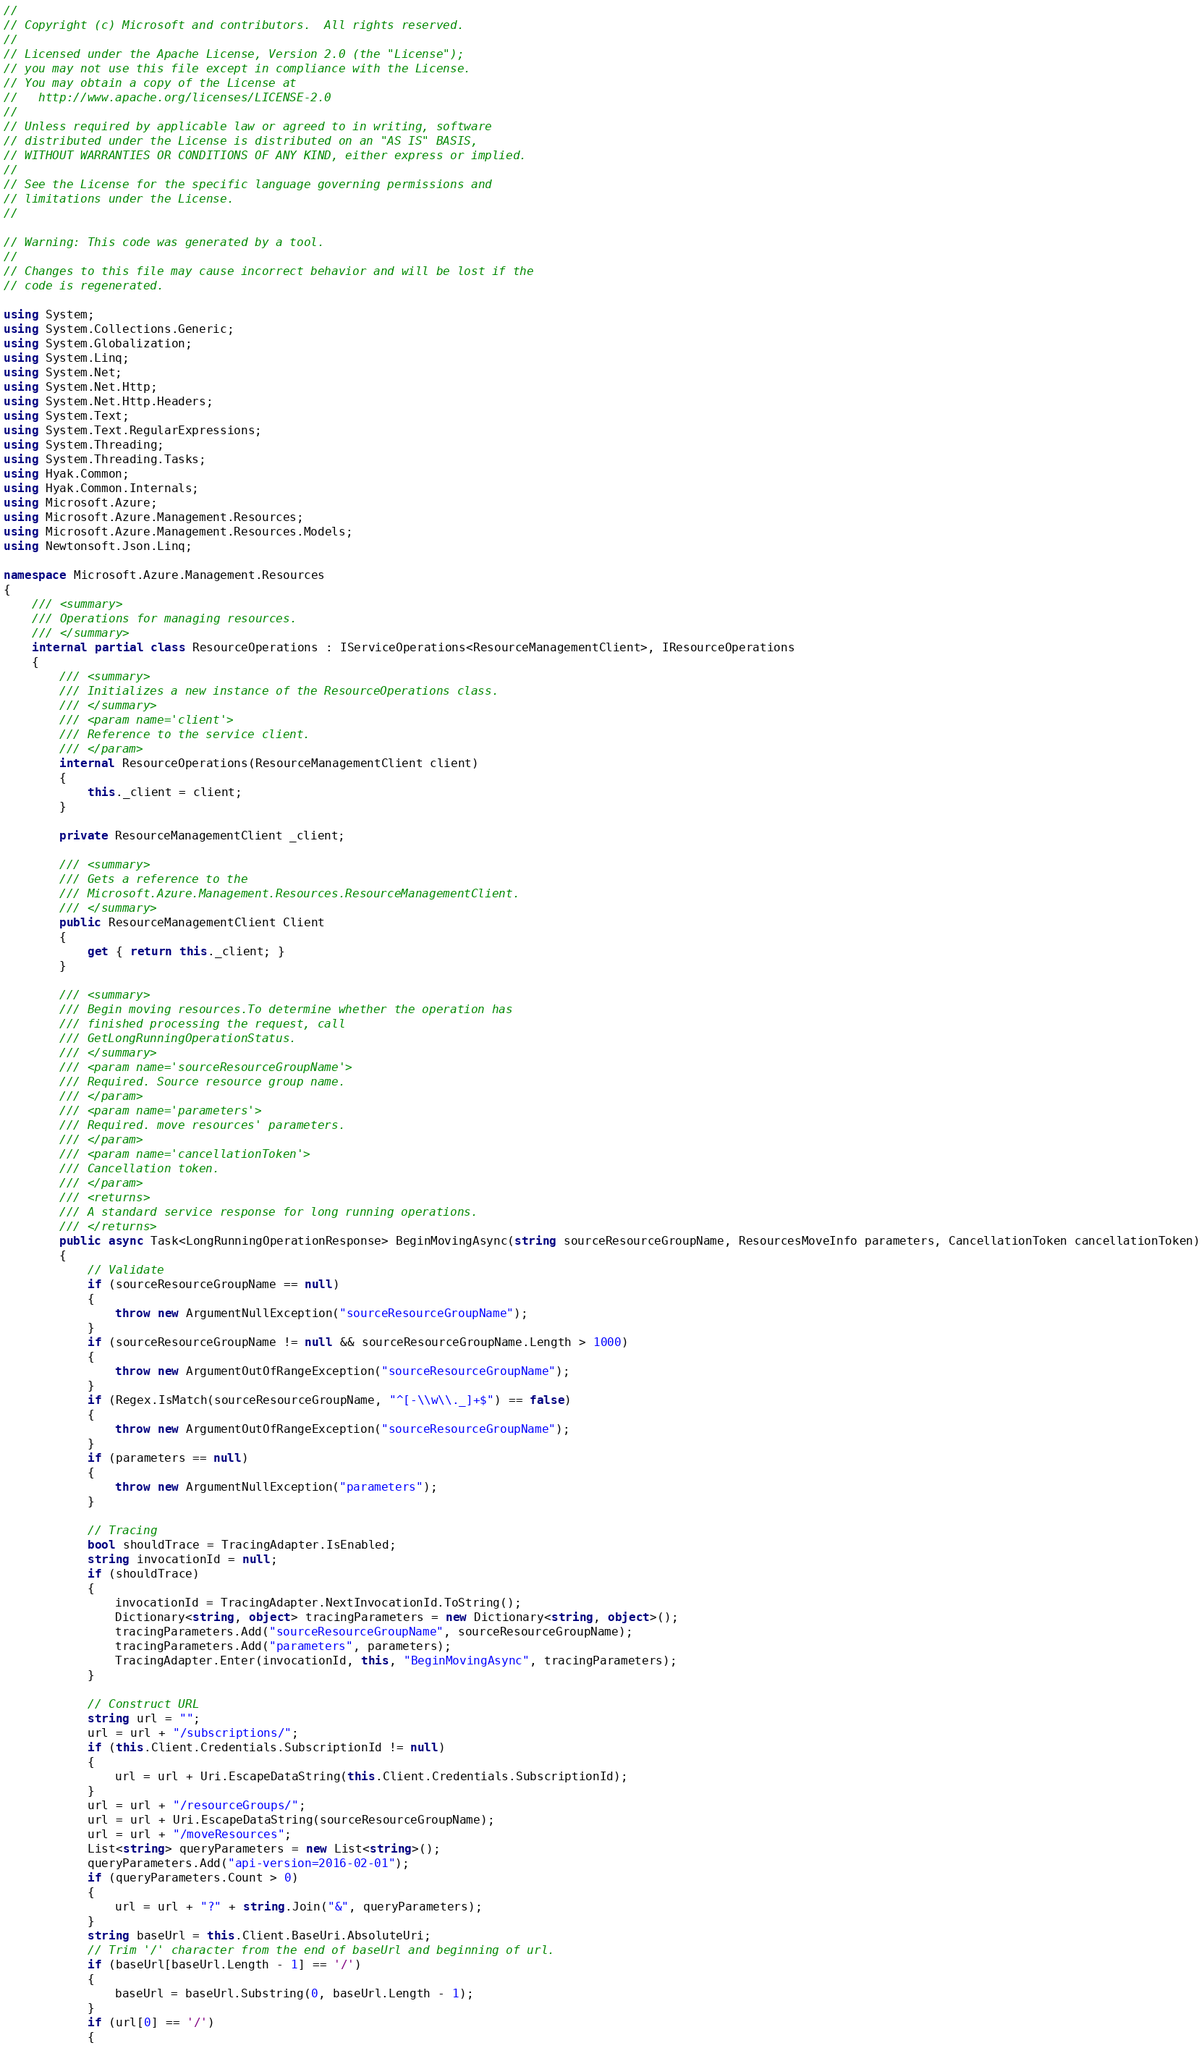<code> <loc_0><loc_0><loc_500><loc_500><_C#_>// 
// Copyright (c) Microsoft and contributors.  All rights reserved.
// 
// Licensed under the Apache License, Version 2.0 (the "License");
// you may not use this file except in compliance with the License.
// You may obtain a copy of the License at
//   http://www.apache.org/licenses/LICENSE-2.0
// 
// Unless required by applicable law or agreed to in writing, software
// distributed under the License is distributed on an "AS IS" BASIS,
// WITHOUT WARRANTIES OR CONDITIONS OF ANY KIND, either express or implied.
// 
// See the License for the specific language governing permissions and
// limitations under the License.
// 

// Warning: This code was generated by a tool.
// 
// Changes to this file may cause incorrect behavior and will be lost if the
// code is regenerated.

using System;
using System.Collections.Generic;
using System.Globalization;
using System.Linq;
using System.Net;
using System.Net.Http;
using System.Net.Http.Headers;
using System.Text;
using System.Text.RegularExpressions;
using System.Threading;
using System.Threading.Tasks;
using Hyak.Common;
using Hyak.Common.Internals;
using Microsoft.Azure;
using Microsoft.Azure.Management.Resources;
using Microsoft.Azure.Management.Resources.Models;
using Newtonsoft.Json.Linq;

namespace Microsoft.Azure.Management.Resources
{
    /// <summary>
    /// Operations for managing resources.
    /// </summary>
    internal partial class ResourceOperations : IServiceOperations<ResourceManagementClient>, IResourceOperations
    {
        /// <summary>
        /// Initializes a new instance of the ResourceOperations class.
        /// </summary>
        /// <param name='client'>
        /// Reference to the service client.
        /// </param>
        internal ResourceOperations(ResourceManagementClient client)
        {
            this._client = client;
        }
        
        private ResourceManagementClient _client;
        
        /// <summary>
        /// Gets a reference to the
        /// Microsoft.Azure.Management.Resources.ResourceManagementClient.
        /// </summary>
        public ResourceManagementClient Client
        {
            get { return this._client; }
        }
        
        /// <summary>
        /// Begin moving resources.To determine whether the operation has
        /// finished processing the request, call
        /// GetLongRunningOperationStatus.
        /// </summary>
        /// <param name='sourceResourceGroupName'>
        /// Required. Source resource group name.
        /// </param>
        /// <param name='parameters'>
        /// Required. move resources' parameters.
        /// </param>
        /// <param name='cancellationToken'>
        /// Cancellation token.
        /// </param>
        /// <returns>
        /// A standard service response for long running operations.
        /// </returns>
        public async Task<LongRunningOperationResponse> BeginMovingAsync(string sourceResourceGroupName, ResourcesMoveInfo parameters, CancellationToken cancellationToken)
        {
            // Validate
            if (sourceResourceGroupName == null)
            {
                throw new ArgumentNullException("sourceResourceGroupName");
            }
            if (sourceResourceGroupName != null && sourceResourceGroupName.Length > 1000)
            {
                throw new ArgumentOutOfRangeException("sourceResourceGroupName");
            }
            if (Regex.IsMatch(sourceResourceGroupName, "^[-\\w\\._]+$") == false)
            {
                throw new ArgumentOutOfRangeException("sourceResourceGroupName");
            }
            if (parameters == null)
            {
                throw new ArgumentNullException("parameters");
            }
            
            // Tracing
            bool shouldTrace = TracingAdapter.IsEnabled;
            string invocationId = null;
            if (shouldTrace)
            {
                invocationId = TracingAdapter.NextInvocationId.ToString();
                Dictionary<string, object> tracingParameters = new Dictionary<string, object>();
                tracingParameters.Add("sourceResourceGroupName", sourceResourceGroupName);
                tracingParameters.Add("parameters", parameters);
                TracingAdapter.Enter(invocationId, this, "BeginMovingAsync", tracingParameters);
            }
            
            // Construct URL
            string url = "";
            url = url + "/subscriptions/";
            if (this.Client.Credentials.SubscriptionId != null)
            {
                url = url + Uri.EscapeDataString(this.Client.Credentials.SubscriptionId);
            }
            url = url + "/resourceGroups/";
            url = url + Uri.EscapeDataString(sourceResourceGroupName);
            url = url + "/moveResources";
            List<string> queryParameters = new List<string>();
            queryParameters.Add("api-version=2016-02-01");
            if (queryParameters.Count > 0)
            {
                url = url + "?" + string.Join("&", queryParameters);
            }
            string baseUrl = this.Client.BaseUri.AbsoluteUri;
            // Trim '/' character from the end of baseUrl and beginning of url.
            if (baseUrl[baseUrl.Length - 1] == '/')
            {
                baseUrl = baseUrl.Substring(0, baseUrl.Length - 1);
            }
            if (url[0] == '/')
            {</code> 